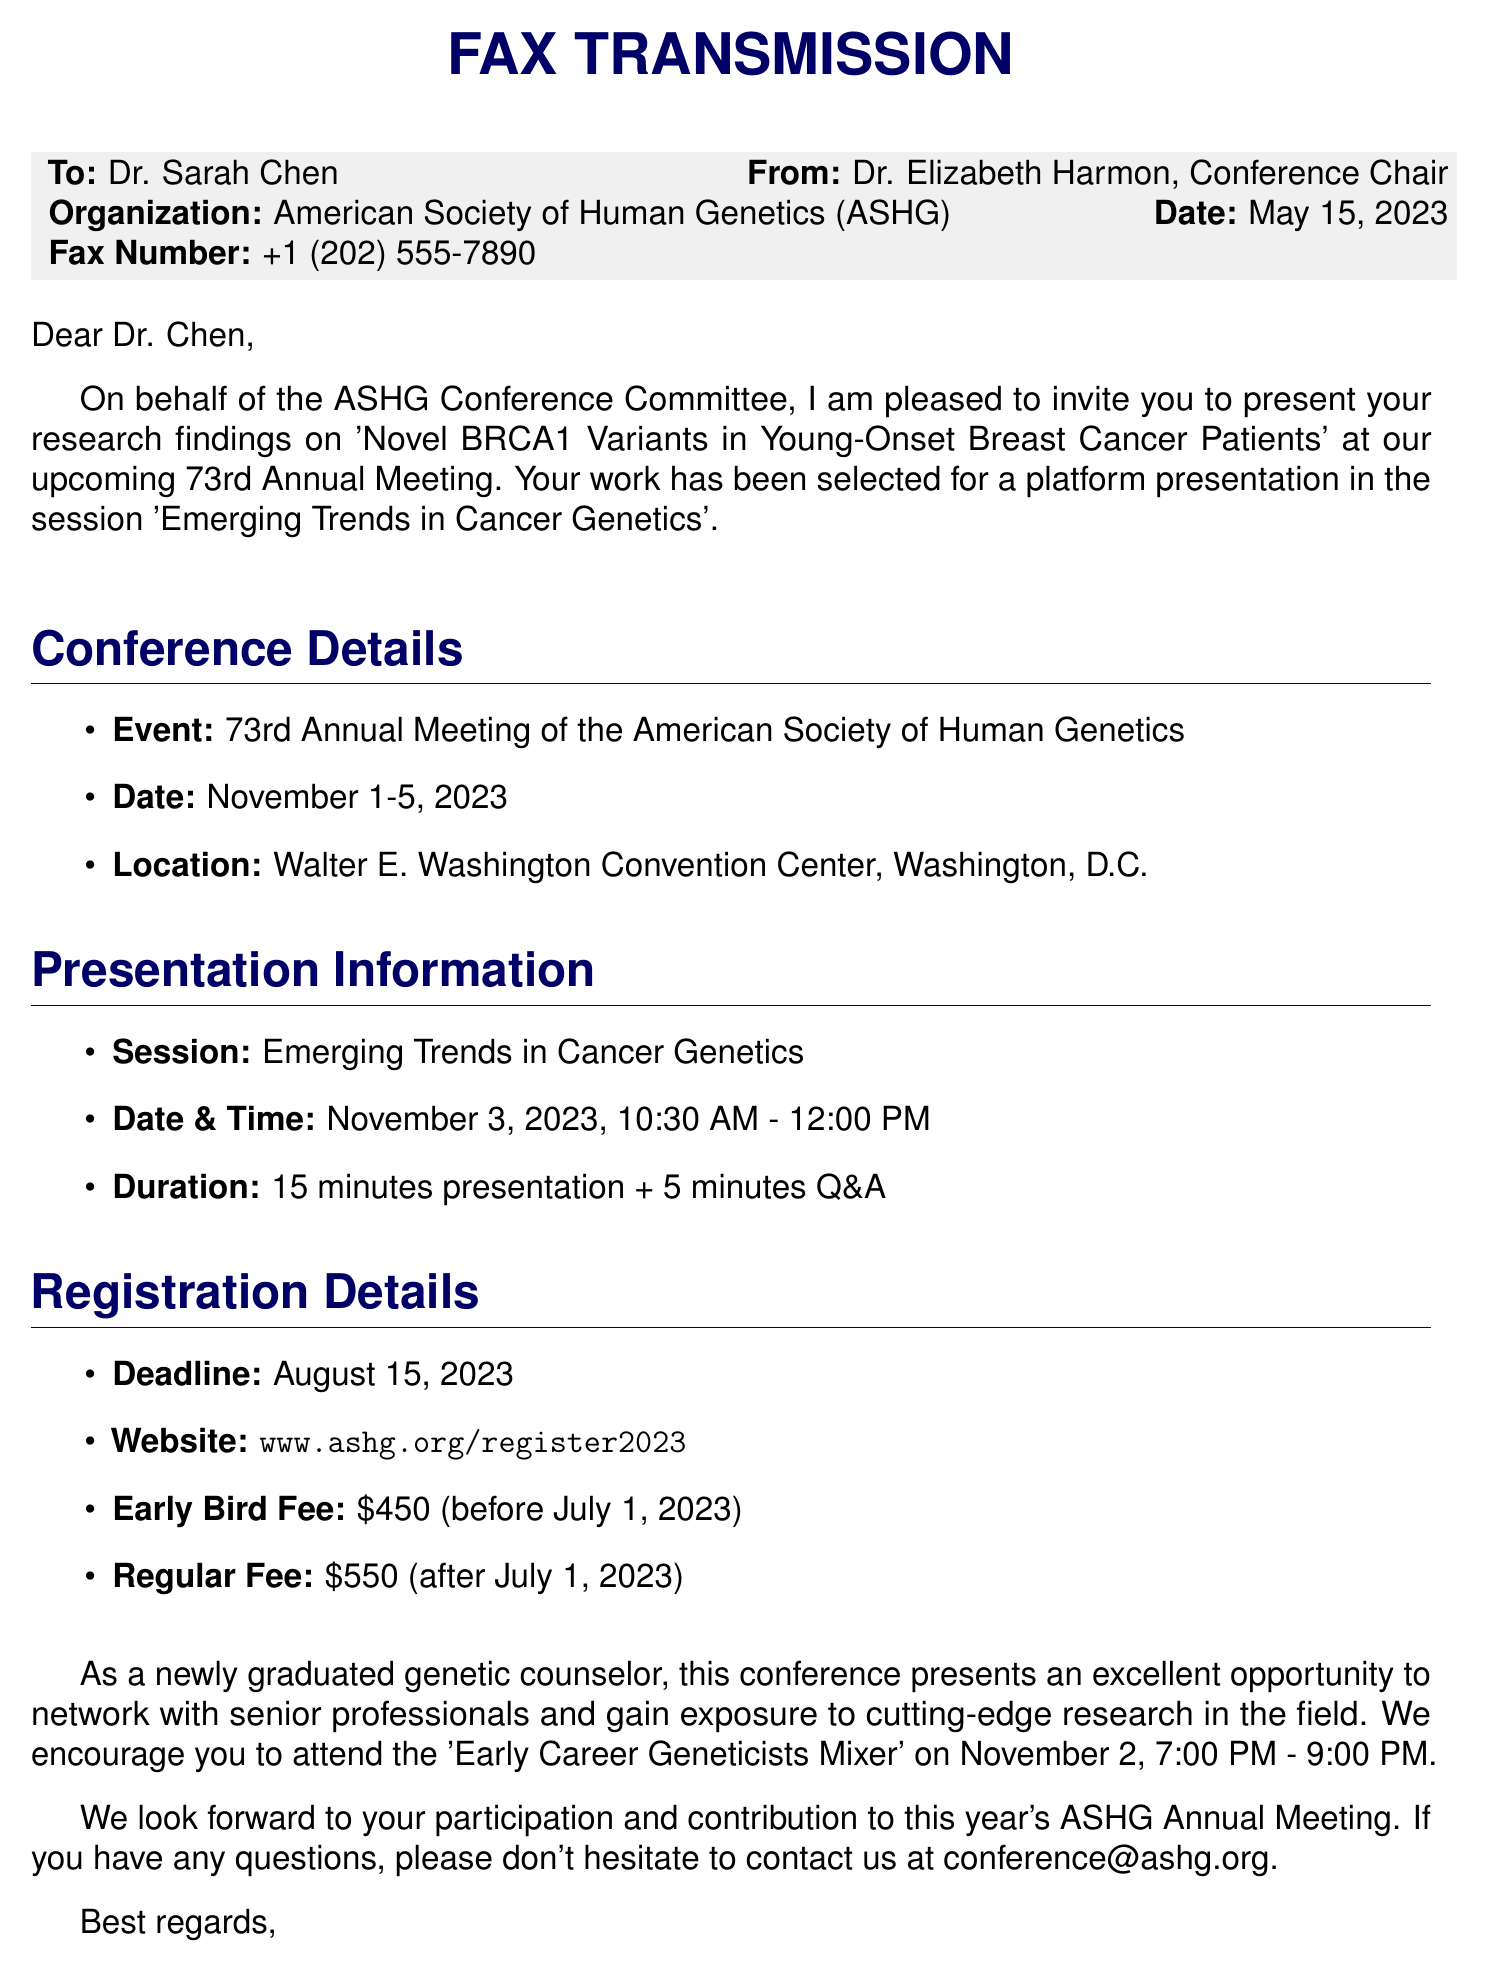What is the name of the conference? The name of the conference is stated in the document as the "73rd Annual Meeting of the American Society of Human Genetics."
Answer: 73rd Annual Meeting of the American Society of Human Genetics Who is the sender of the fax? The sender of the fax is mentioned at the top of the document.
Answer: Dr. Elizabeth Harmon What date is the presentation scheduled for? The specific date for the presentation is indicated in the presentation information section of the document.
Answer: November 3, 2023 What is the early bird registration fee? The early bird registration fee is listed in the registration details section of the fax.
Answer: $450 What is the location of the conference? The location of the conference is provided under the conference details section.
Answer: Walter E. Washington Convention Center, Washington, D.C How long is the presentation plus Q&A? The total time for the presentation and Q&A is provided in the presentation information section.
Answer: 20 minutes What is the registration deadline? The registration deadline is clearly stated in the registration details section of the document.
Answer: August 15, 2023 What event is suggested for networking? The document mentions an event specifically designed for networking.
Answer: Early Career Geneticists Mixer 